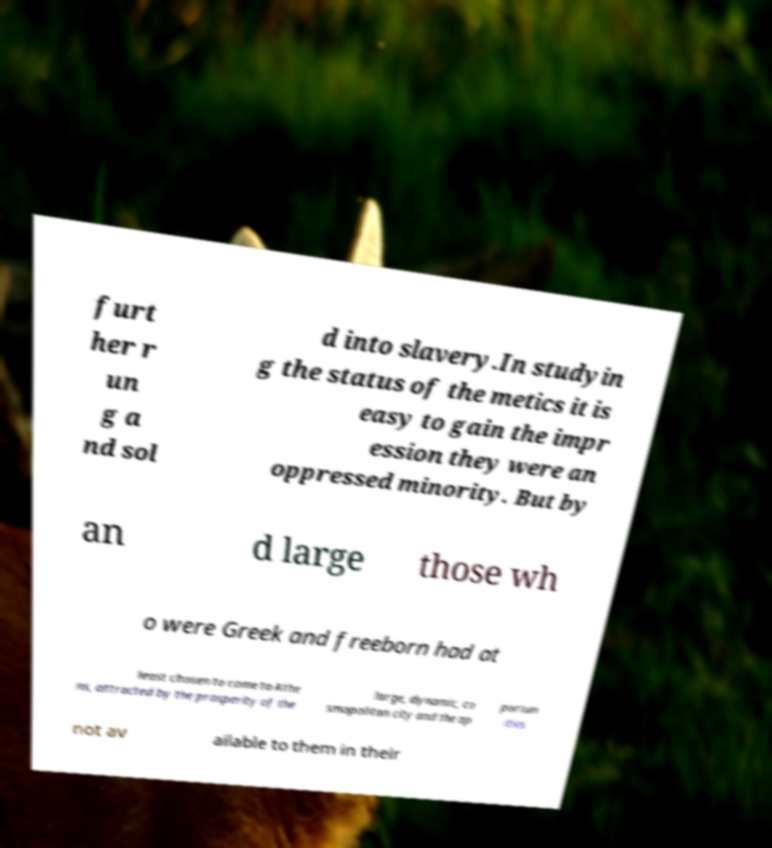Could you assist in decoding the text presented in this image and type it out clearly? furt her r un g a nd sol d into slavery.In studyin g the status of the metics it is easy to gain the impr ession they were an oppressed minority. But by an d large those wh o were Greek and freeborn had at least chosen to come to Athe ns, attracted by the prosperity of the large, dynamic, co smopolitan city and the op portun ities not av ailable to them in their 